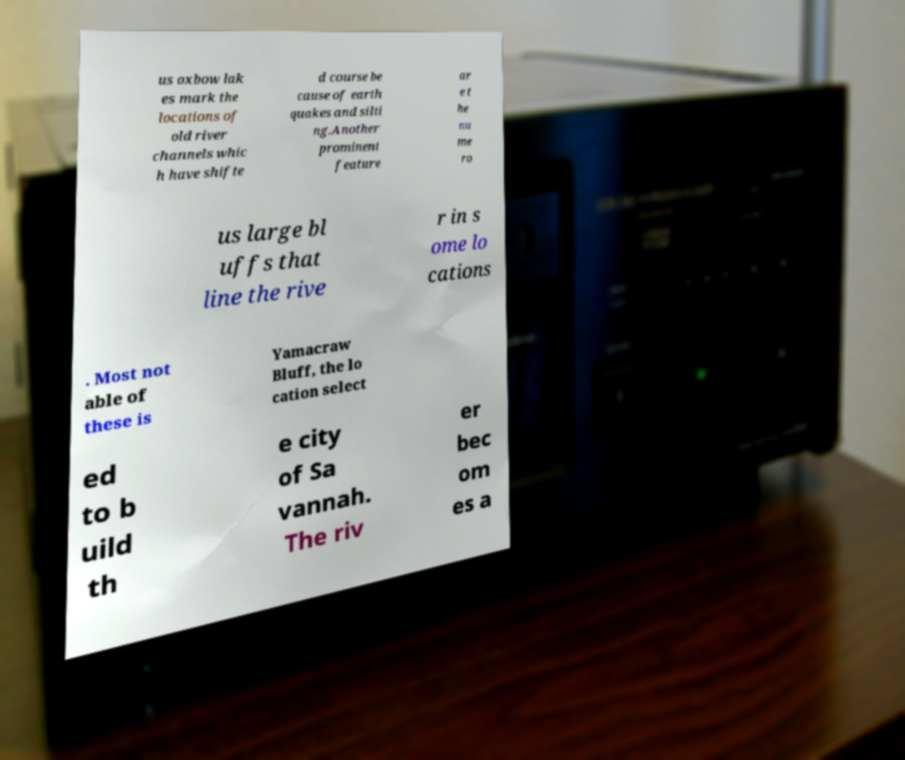Could you assist in decoding the text presented in this image and type it out clearly? us oxbow lak es mark the locations of old river channels whic h have shifte d course be cause of earth quakes and silti ng.Another prominent feature ar e t he nu me ro us large bl uffs that line the rive r in s ome lo cations . Most not able of these is Yamacraw Bluff, the lo cation select ed to b uild th e city of Sa vannah. The riv er bec om es a 